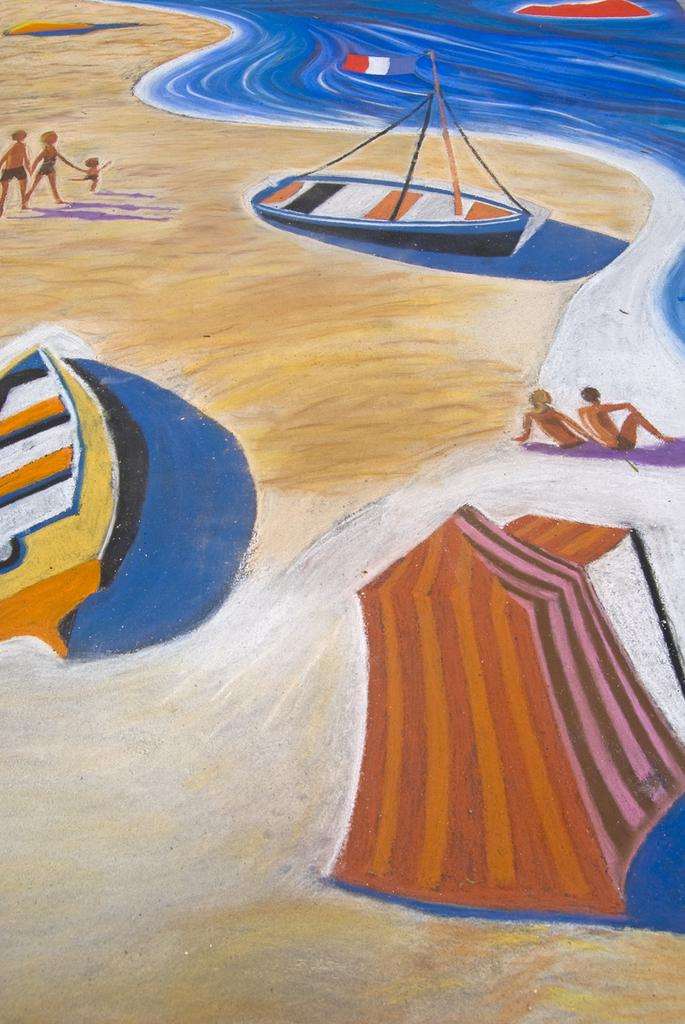What type of artwork is depicted in the image? The image is a painting. What natural setting is featured in the painting? There is a beach area in the painting. What man-made objects can be seen in the painting? There are boats in the painting. What body of water is present in the painting? There is a sea in the painting. Where are the grapes being stored in the painting? There are no grapes present in the painting; it features a beach area, boats, and a sea. What type of scissors can be seen cutting the grass in the painting? There are no scissors or grass cutting activity depicted in the painting. 